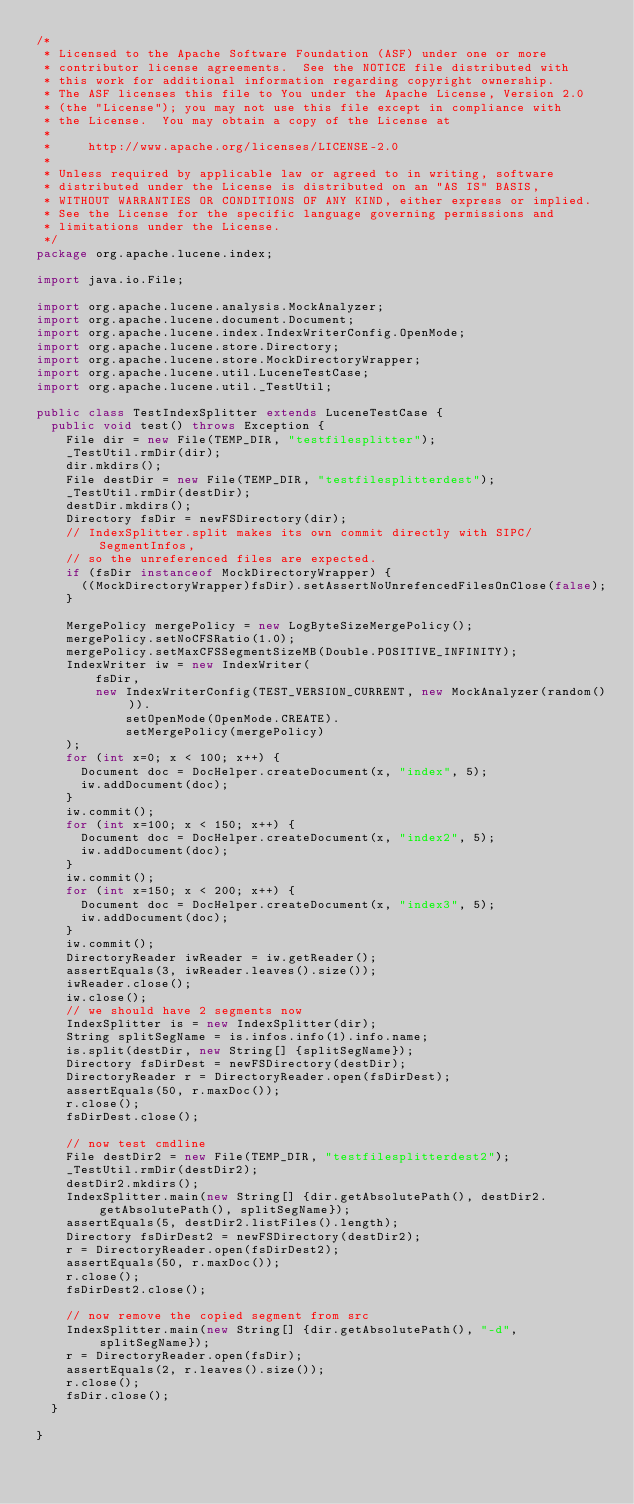<code> <loc_0><loc_0><loc_500><loc_500><_Java_>/*
 * Licensed to the Apache Software Foundation (ASF) under one or more
 * contributor license agreements.  See the NOTICE file distributed with
 * this work for additional information regarding copyright ownership.
 * The ASF licenses this file to You under the Apache License, Version 2.0
 * (the "License"); you may not use this file except in compliance with
 * the License.  You may obtain a copy of the License at
 *
 *     http://www.apache.org/licenses/LICENSE-2.0
 *
 * Unless required by applicable law or agreed to in writing, software
 * distributed under the License is distributed on an "AS IS" BASIS,
 * WITHOUT WARRANTIES OR CONDITIONS OF ANY KIND, either express or implied.
 * See the License for the specific language governing permissions and
 * limitations under the License.
 */
package org.apache.lucene.index;

import java.io.File;

import org.apache.lucene.analysis.MockAnalyzer;
import org.apache.lucene.document.Document;
import org.apache.lucene.index.IndexWriterConfig.OpenMode;
import org.apache.lucene.store.Directory;
import org.apache.lucene.store.MockDirectoryWrapper;
import org.apache.lucene.util.LuceneTestCase;
import org.apache.lucene.util._TestUtil;

public class TestIndexSplitter extends LuceneTestCase {
  public void test() throws Exception {
    File dir = new File(TEMP_DIR, "testfilesplitter");
    _TestUtil.rmDir(dir);
    dir.mkdirs();
    File destDir = new File(TEMP_DIR, "testfilesplitterdest");
    _TestUtil.rmDir(destDir);
    destDir.mkdirs();
    Directory fsDir = newFSDirectory(dir);
    // IndexSplitter.split makes its own commit directly with SIPC/SegmentInfos,
    // so the unreferenced files are expected.
    if (fsDir instanceof MockDirectoryWrapper) {
      ((MockDirectoryWrapper)fsDir).setAssertNoUnrefencedFilesOnClose(false);
    }

    MergePolicy mergePolicy = new LogByteSizeMergePolicy();
    mergePolicy.setNoCFSRatio(1.0);
    mergePolicy.setMaxCFSSegmentSizeMB(Double.POSITIVE_INFINITY);
    IndexWriter iw = new IndexWriter(
        fsDir,
        new IndexWriterConfig(TEST_VERSION_CURRENT, new MockAnalyzer(random())).
            setOpenMode(OpenMode.CREATE).
            setMergePolicy(mergePolicy)
    );
    for (int x=0; x < 100; x++) {
      Document doc = DocHelper.createDocument(x, "index", 5);
      iw.addDocument(doc);
    }
    iw.commit();
    for (int x=100; x < 150; x++) {
      Document doc = DocHelper.createDocument(x, "index2", 5);
      iw.addDocument(doc);
    }
    iw.commit();
    for (int x=150; x < 200; x++) {
      Document doc = DocHelper.createDocument(x, "index3", 5);
      iw.addDocument(doc);
    }
    iw.commit();
    DirectoryReader iwReader = iw.getReader();
    assertEquals(3, iwReader.leaves().size());
    iwReader.close();
    iw.close();
    // we should have 2 segments now
    IndexSplitter is = new IndexSplitter(dir);
    String splitSegName = is.infos.info(1).info.name;
    is.split(destDir, new String[] {splitSegName});
    Directory fsDirDest = newFSDirectory(destDir);
    DirectoryReader r = DirectoryReader.open(fsDirDest);
    assertEquals(50, r.maxDoc());
    r.close();
    fsDirDest.close();
    
    // now test cmdline
    File destDir2 = new File(TEMP_DIR, "testfilesplitterdest2");
    _TestUtil.rmDir(destDir2);
    destDir2.mkdirs();
    IndexSplitter.main(new String[] {dir.getAbsolutePath(), destDir2.getAbsolutePath(), splitSegName});
    assertEquals(5, destDir2.listFiles().length);
    Directory fsDirDest2 = newFSDirectory(destDir2);
    r = DirectoryReader.open(fsDirDest2);
    assertEquals(50, r.maxDoc());
    r.close();
    fsDirDest2.close();
    
    // now remove the copied segment from src
    IndexSplitter.main(new String[] {dir.getAbsolutePath(), "-d", splitSegName});
    r = DirectoryReader.open(fsDir);
    assertEquals(2, r.leaves().size());
    r.close();
    fsDir.close();
  }

}
</code> 